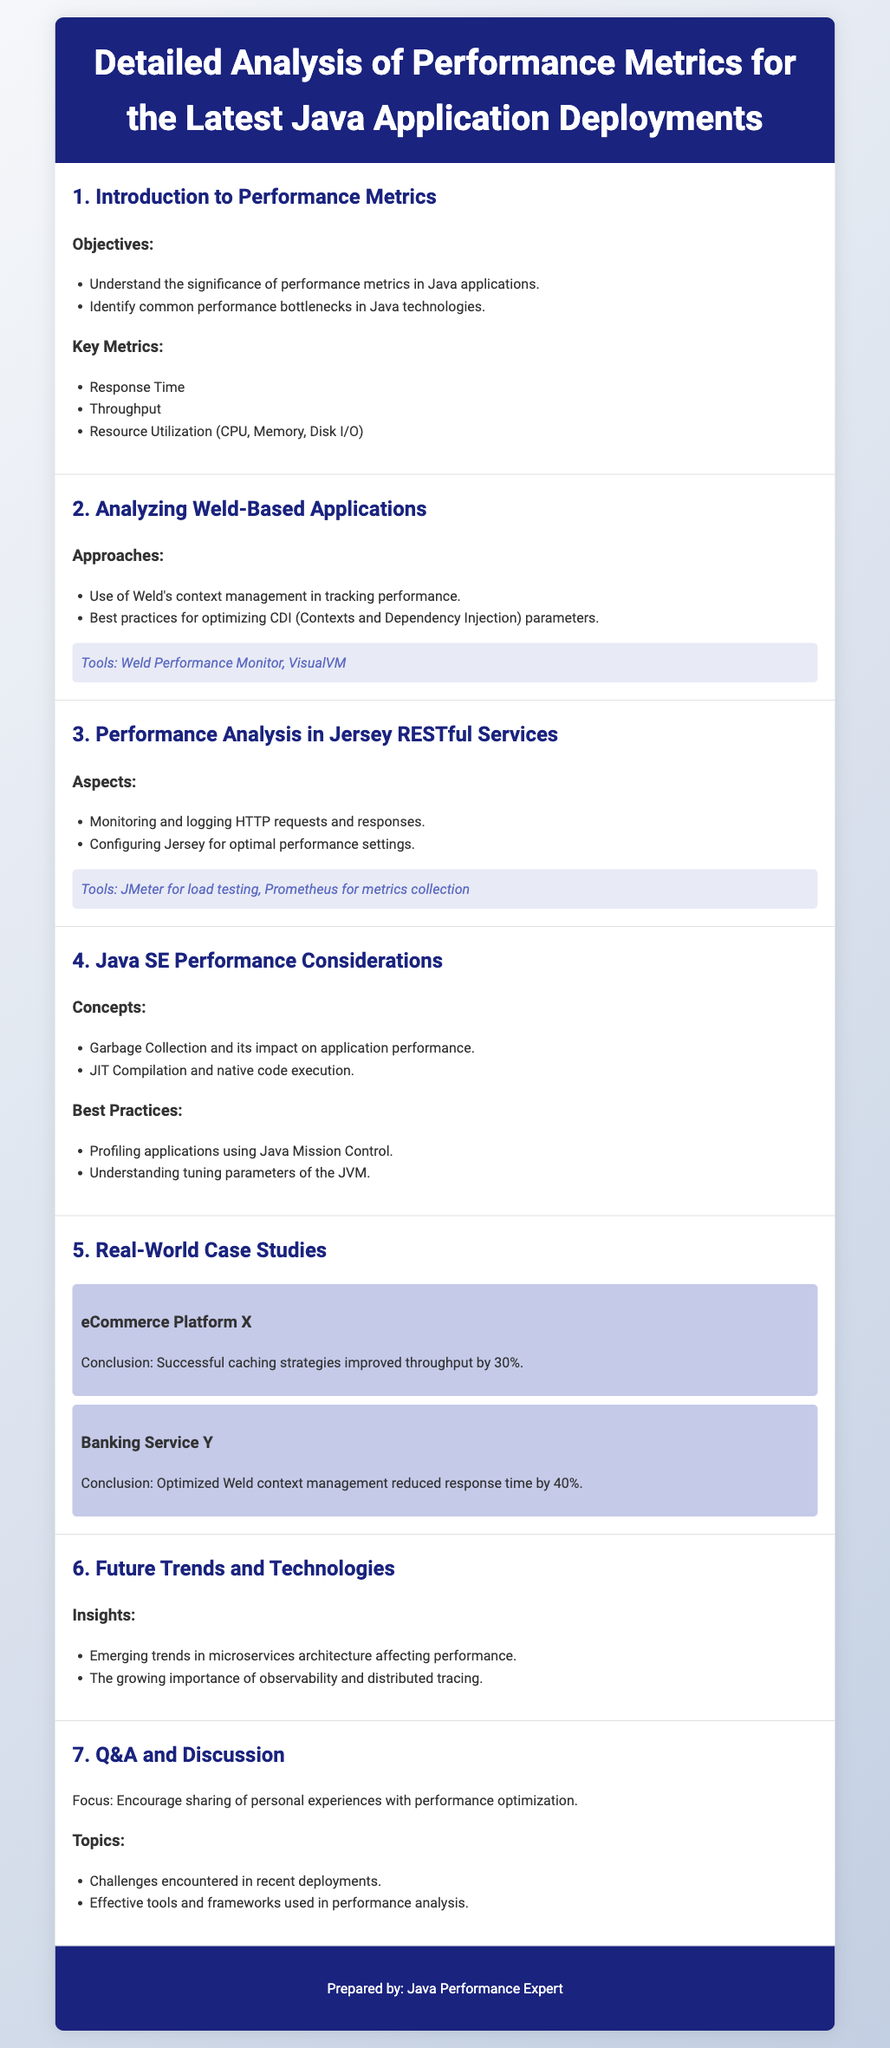What are the key performance metrics? The document lists Response Time, Throughput, and Resource Utilization as key performance metrics.
Answer: Response Time, Throughput, Resource Utilization What tool is suggested for load testing in Jersey RESTful Services? The document mentions JMeter as a tool for load testing.
Answer: JMeter What is the conclusion from the case study of Banking Service Y? The case study concludes that optimized Weld context management reduced response time by 40%.
Answer: Reduced response time by 40% What performance aspect does Garbage Collection affect? The document states that Garbage Collection impacts application performance.
Answer: Application performance What are the emerging trends mentioned in the document? The insights include microservices architecture and the importance of observability and distributed tracing.
Answer: Microservices architecture, observability, distributed tracing What context management tool is referenced for Weld-based applications? The document highlights Weld Performance Monitor as a tool for Weld-based applications.
Answer: Weld Performance Monitor 